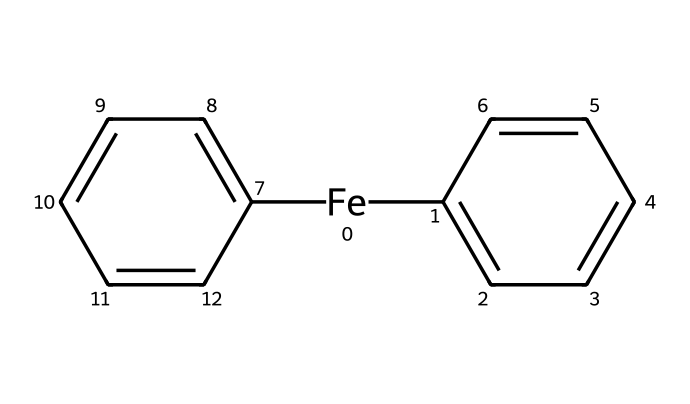What is the metal center in this compound? The structure indicates a central iron atom, as it is denoted by [Fe] in the SMILES representation.
Answer: iron How many carbon atoms are present in ferrocene? The two cyclopentadienyl rings each contribute five carbon atoms, totaling ten carbon atoms in the structure.
Answer: ten What type of bonding is primarily present in ferrocene? The iron atom is sandwiched between two cyclopentadienyl rings that engage in π-bonding, specifically η^5 coordination with the metal.
Answer: covalent What is the primary hybridization of the carbon atoms in the cyclopentadienyl rings? The carbon atoms in the cyclopentadienyl rings are sp2 hybridized, which is typical for aromatic systems with double bonds.
Answer: sp2 Why is ferrocene considered a 'sandwich compound'? The term 'sandwich' arises from its distinct structure where an iron atom is enclosed between two parallel cyclopentadienyl rings, resembling a sandwich.
Answer: sandwich How many double bonds are found in each cyclopentadienyl ring of ferrocene? Each cyclopentadienyl ring contains four π-bonds, as there are five carbon atoms in a ring with alternating double bonds (in a conjugated π-system).
Answer: four What is the overall molecular formula of ferrocene? By combining the composition from the iron atom (Fe) and the two cyclopentadienyl rings (C10H10), the overall molecular formula is C10H10Fe.
Answer: C10H10Fe 